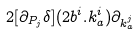Convert formula to latex. <formula><loc_0><loc_0><loc_500><loc_500>2 [ \partial _ { P _ { j } } \delta ] ( 2 b ^ { i } . k ^ { i } _ { a } ) \partial _ { k ^ { j } _ { a } }</formula> 